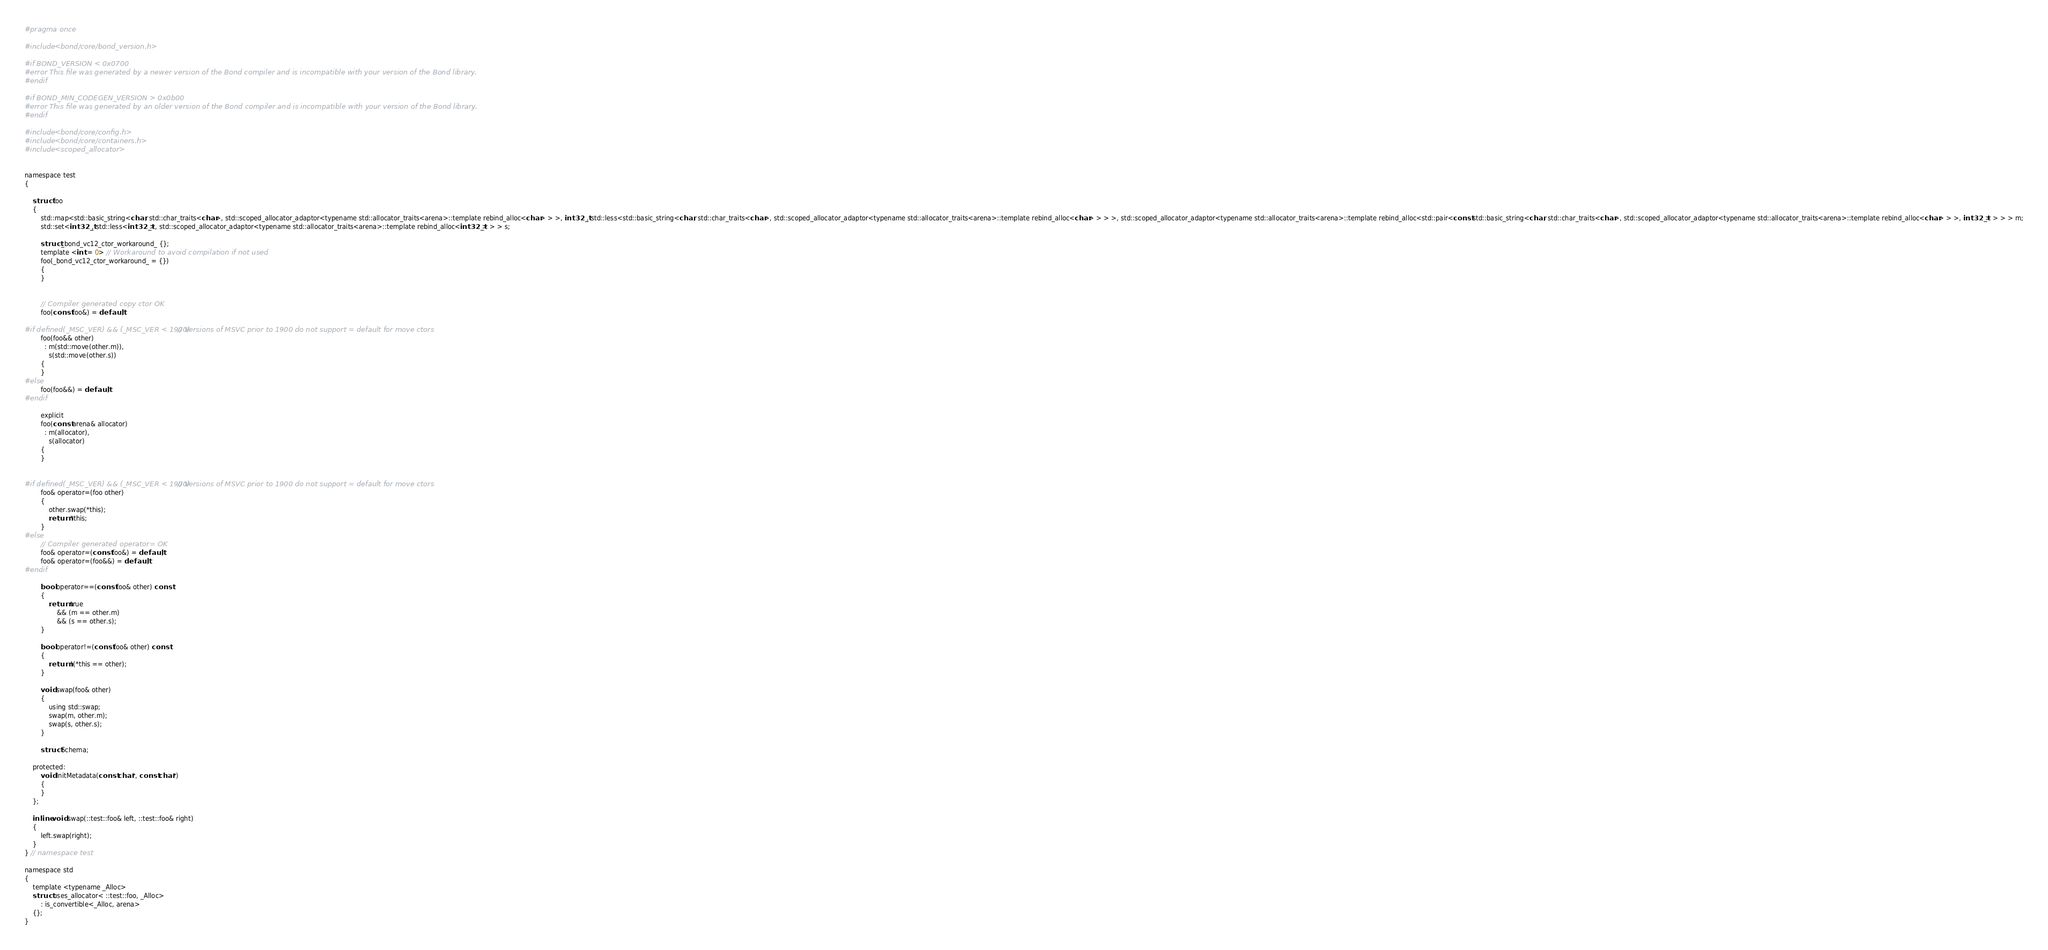Convert code to text. <code><loc_0><loc_0><loc_500><loc_500><_C_>
#pragma once

#include <bond/core/bond_version.h>

#if BOND_VERSION < 0x0700
#error This file was generated by a newer version of the Bond compiler and is incompatible with your version of the Bond library.
#endif

#if BOND_MIN_CODEGEN_VERSION > 0x0b00
#error This file was generated by an older version of the Bond compiler and is incompatible with your version of the Bond library.
#endif

#include <bond/core/config.h>
#include <bond/core/containers.h>
#include <scoped_allocator>


namespace test
{
    
    struct foo
    {
        std::map<std::basic_string<char, std::char_traits<char>, std::scoped_allocator_adaptor<typename std::allocator_traits<arena>::template rebind_alloc<char> > >, int32_t, std::less<std::basic_string<char, std::char_traits<char>, std::scoped_allocator_adaptor<typename std::allocator_traits<arena>::template rebind_alloc<char> > > >, std::scoped_allocator_adaptor<typename std::allocator_traits<arena>::template rebind_alloc<std::pair<const std::basic_string<char, std::char_traits<char>, std::scoped_allocator_adaptor<typename std::allocator_traits<arena>::template rebind_alloc<char> > >, int32_t> > > > m;
        std::set<int32_t, std::less<int32_t>, std::scoped_allocator_adaptor<typename std::allocator_traits<arena>::template rebind_alloc<int32_t> > > s;
        
        struct _bond_vc12_ctor_workaround_ {};
        template <int = 0> // Workaround to avoid compilation if not used
        foo(_bond_vc12_ctor_workaround_ = {})
        {
        }

        
        // Compiler generated copy ctor OK
        foo(const foo&) = default;
        
#if defined(_MSC_VER) && (_MSC_VER < 1900)  // Versions of MSVC prior to 1900 do not support = default for move ctors
        foo(foo&& other)
          : m(std::move(other.m)),
            s(std::move(other.s))
        {
        }
#else
        foo(foo&&) = default;
#endif
        
        explicit
        foo(const arena& allocator)
          : m(allocator),
            s(allocator)
        {
        }
        
        
#if defined(_MSC_VER) && (_MSC_VER < 1900)  // Versions of MSVC prior to 1900 do not support = default for move ctors
        foo& operator=(foo other)
        {
            other.swap(*this);
            return *this;
        }
#else
        // Compiler generated operator= OK
        foo& operator=(const foo&) = default;
        foo& operator=(foo&&) = default;
#endif

        bool operator==(const foo& other) const
        {
            return true
                && (m == other.m)
                && (s == other.s);
        }

        bool operator!=(const foo& other) const
        {
            return !(*this == other);
        }

        void swap(foo& other)
        {
            using std::swap;
            swap(m, other.m);
            swap(s, other.s);
        }

        struct Schema;

    protected:
        void InitMetadata(const char*, const char*)
        {
        }
    };

    inline void swap(::test::foo& left, ::test::foo& right)
    {
        left.swap(right);
    }
} // namespace test

namespace std
{
    template <typename _Alloc>
    struct uses_allocator< ::test::foo, _Alloc>
        : is_convertible<_Alloc, arena>
    {};
}

</code> 